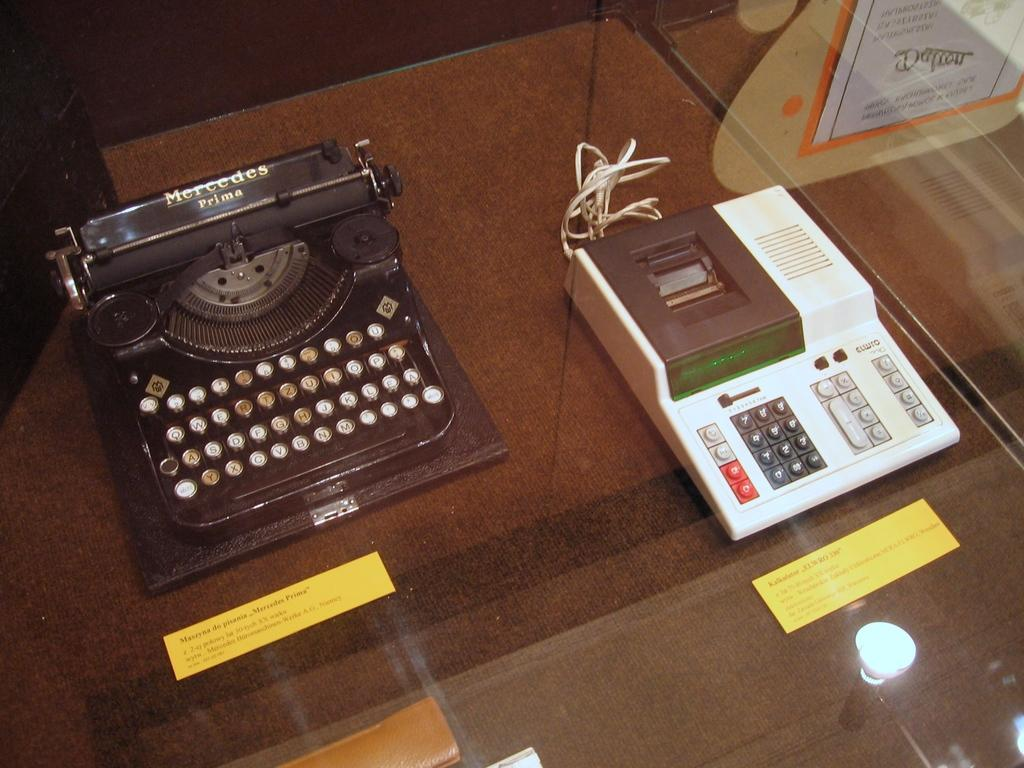<image>
Describe the image concisely. Two old typewrites are on display, one of which is a Mercedes Prime. 